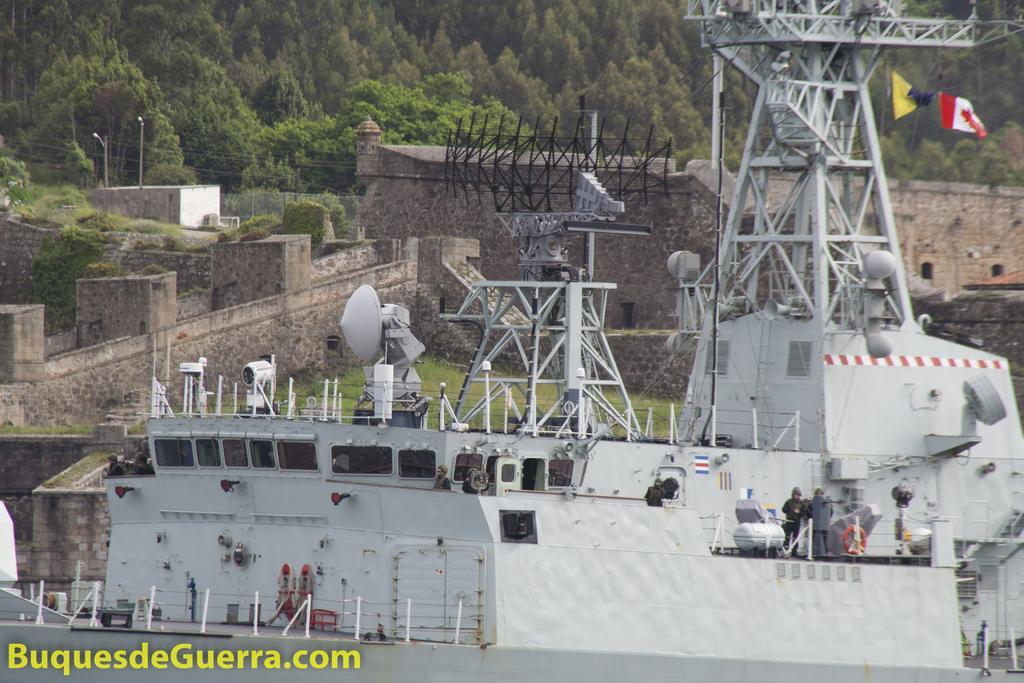Can you describe this image briefly? In the image there are towers with antennas, dish antenna, railing, flags and glass windows. And also there are few people standing. In the background there are walls, pillars and also there are many trees. 